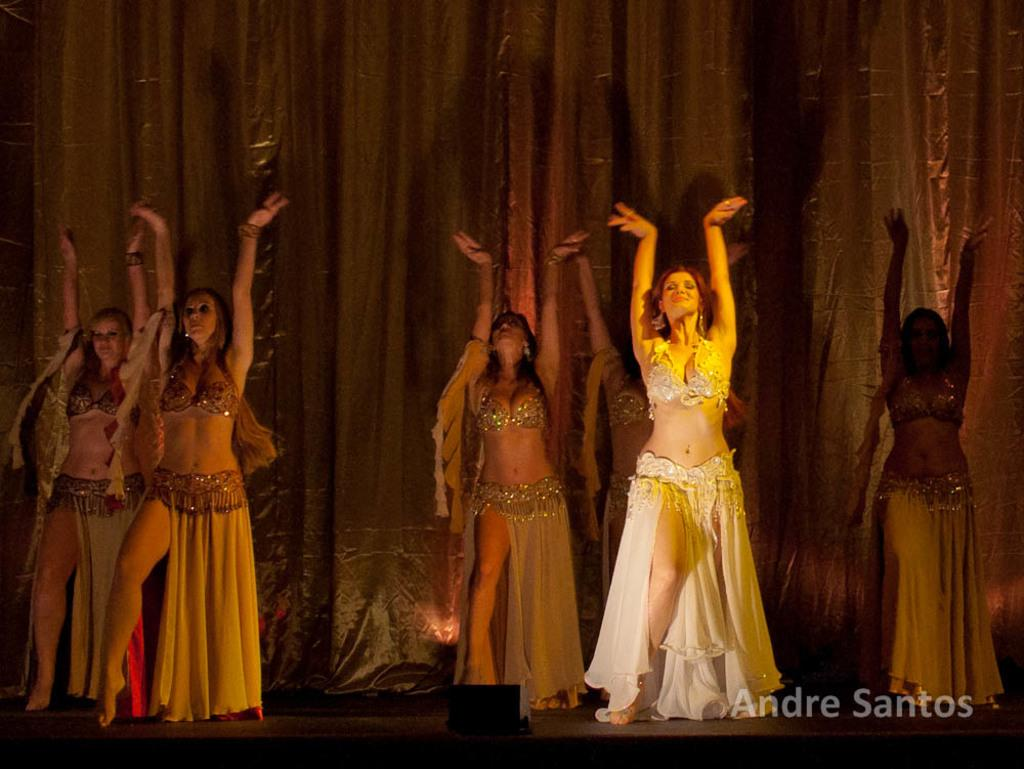How many people are present in the image? There are 6 women in the image. What are the women wearing? The women are wearing the same costumes. Can you describe any additional features in the image? There is a watermark and a curtain in the background of the image. What type of jeans are the women wearing in the image? The women are not wearing jeans in the image; they are wearing the same costumes. What belief system do the women in the image follow? There is no information about the women's beliefs in the image. 